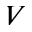<formula> <loc_0><loc_0><loc_500><loc_500>_ { V }</formula> 